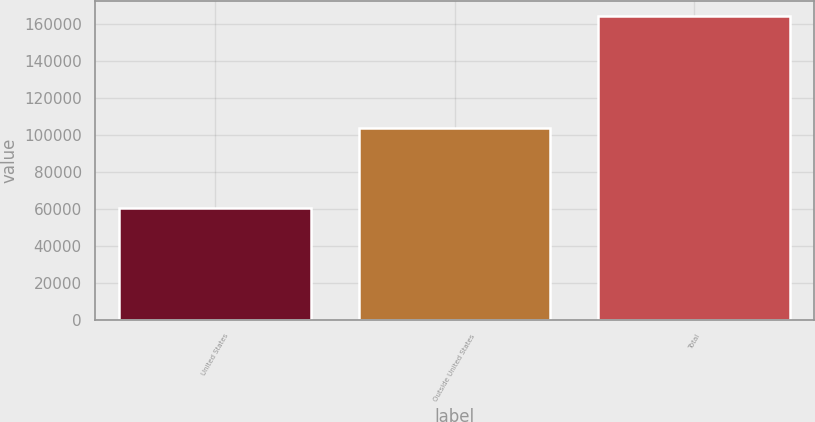<chart> <loc_0><loc_0><loc_500><loc_500><bar_chart><fcel>United States<fcel>Outside United States<fcel>Total<nl><fcel>60388<fcel>103786<fcel>164174<nl></chart> 